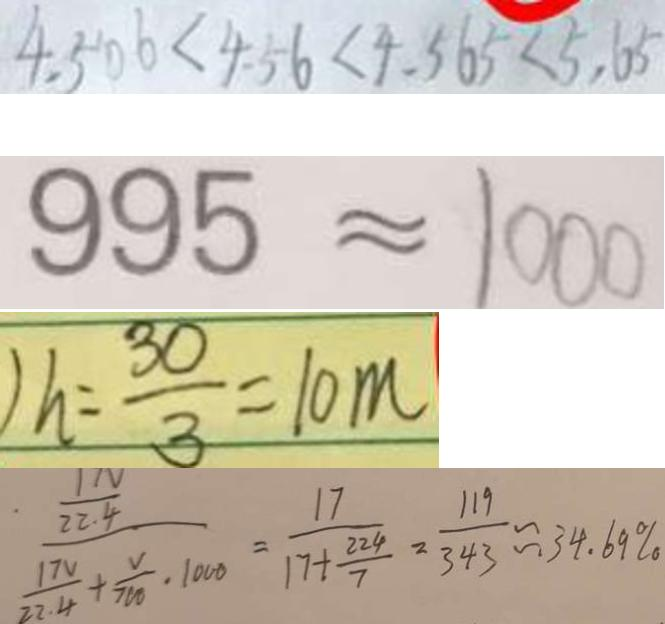Convert formula to latex. <formula><loc_0><loc_0><loc_500><loc_500>4 . 5 0 6 < 4 . 5 6 < 4 . 5 6 5 < 5 . 6 5 
 9 9 5 \approx 1 0 0 0 
 ) h = \frac { 3 0 } { 3 } = 1 0 m 
 \frac { \frac { 1 N } { 2 2 . 4 } } { \frac { 1 7 V } { 2 2 . 4 } + \frac { V } { 7 0 0 } \cdot 1 0 0 0 } = \frac { 1 7 } { 1 7 + \frac { 2 2 4 } { 7 } } = \frac { 1 1 9 } { 3 4 3 } \approx 3 4 . 6 9 \%</formula> 